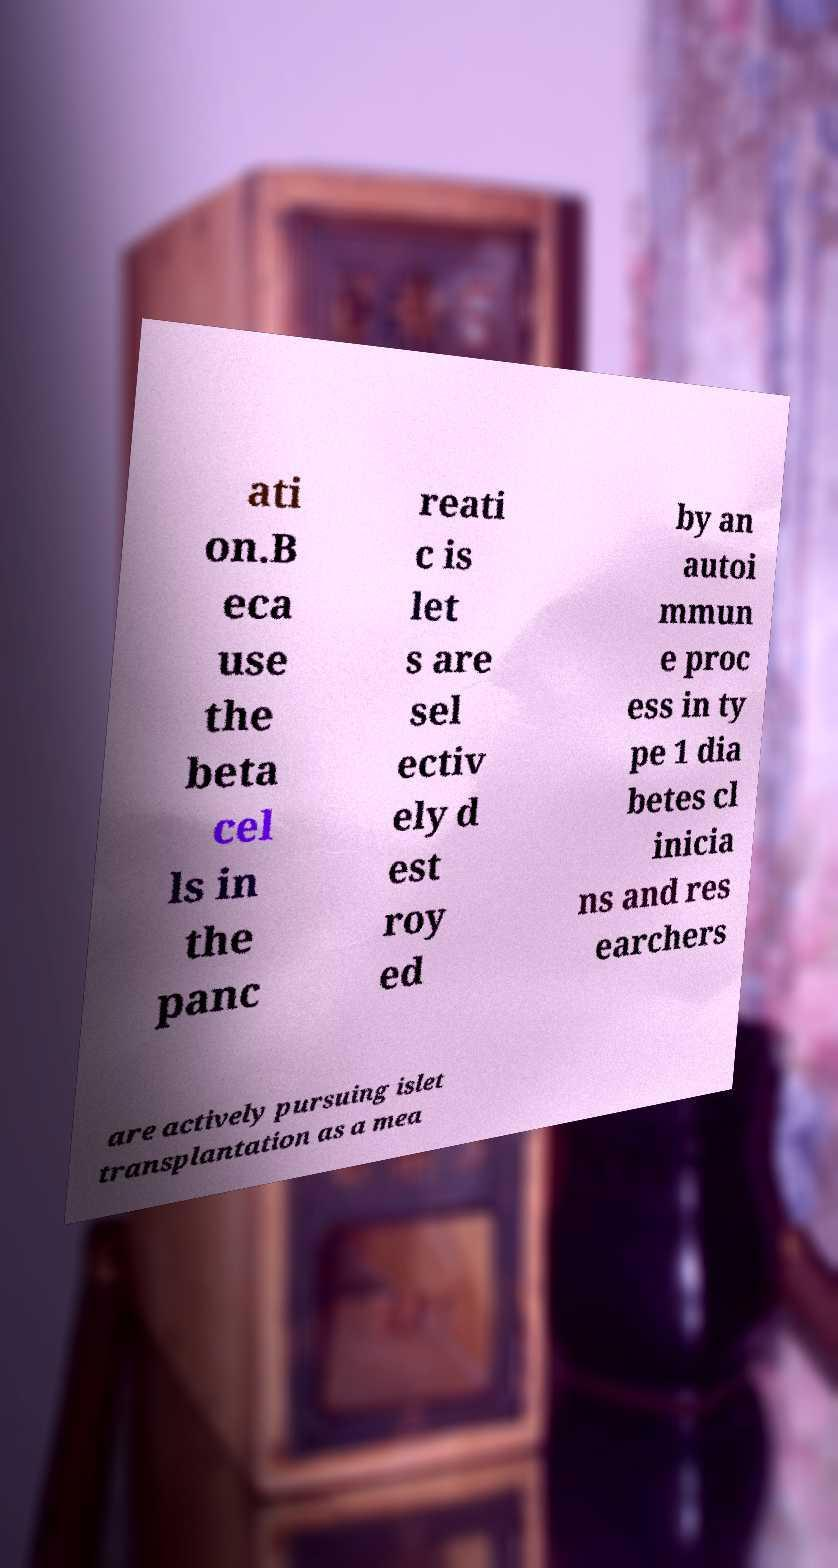Can you accurately transcribe the text from the provided image for me? ati on.B eca use the beta cel ls in the panc reati c is let s are sel ectiv ely d est roy ed by an autoi mmun e proc ess in ty pe 1 dia betes cl inicia ns and res earchers are actively pursuing islet transplantation as a mea 